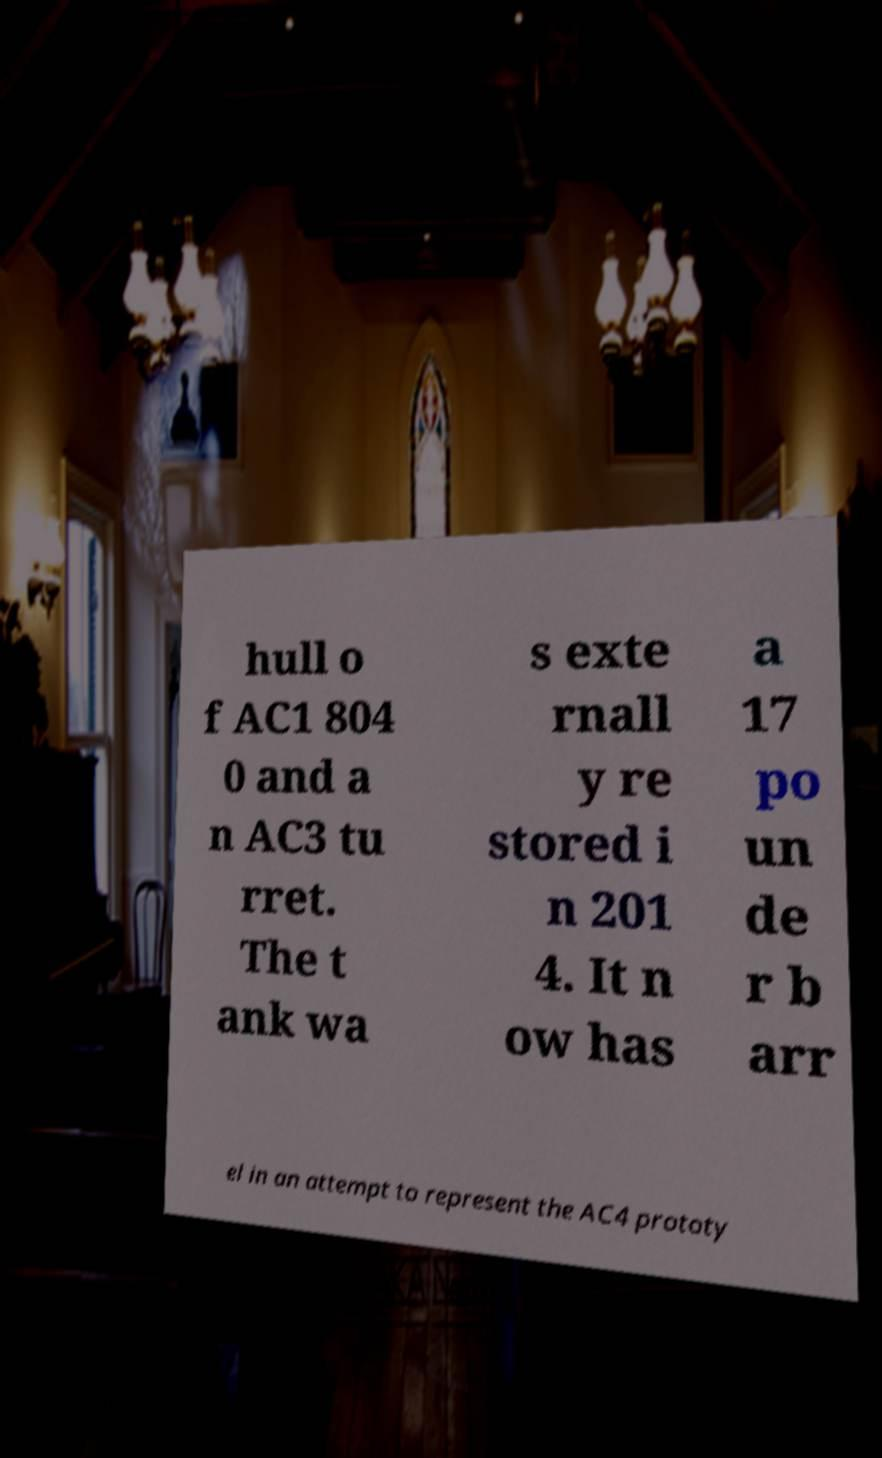Please identify and transcribe the text found in this image. hull o f AC1 804 0 and a n AC3 tu rret. The t ank wa s exte rnall y re stored i n 201 4. It n ow has a 17 po un de r b arr el in an attempt to represent the AC4 prototy 